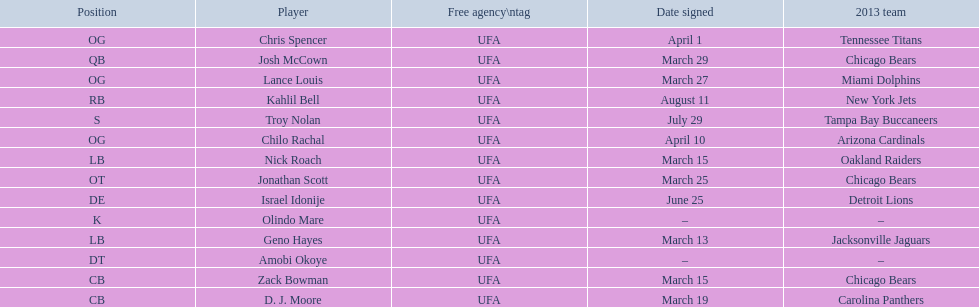What are all the dates signed? March 29, August 11, March 27, April 1, April 10, March 25, June 25, March 13, March 15, March 15, March 19, July 29. Which of these are duplicates? March 15, March 15. Who has the same one as nick roach? Zack Bowman. 